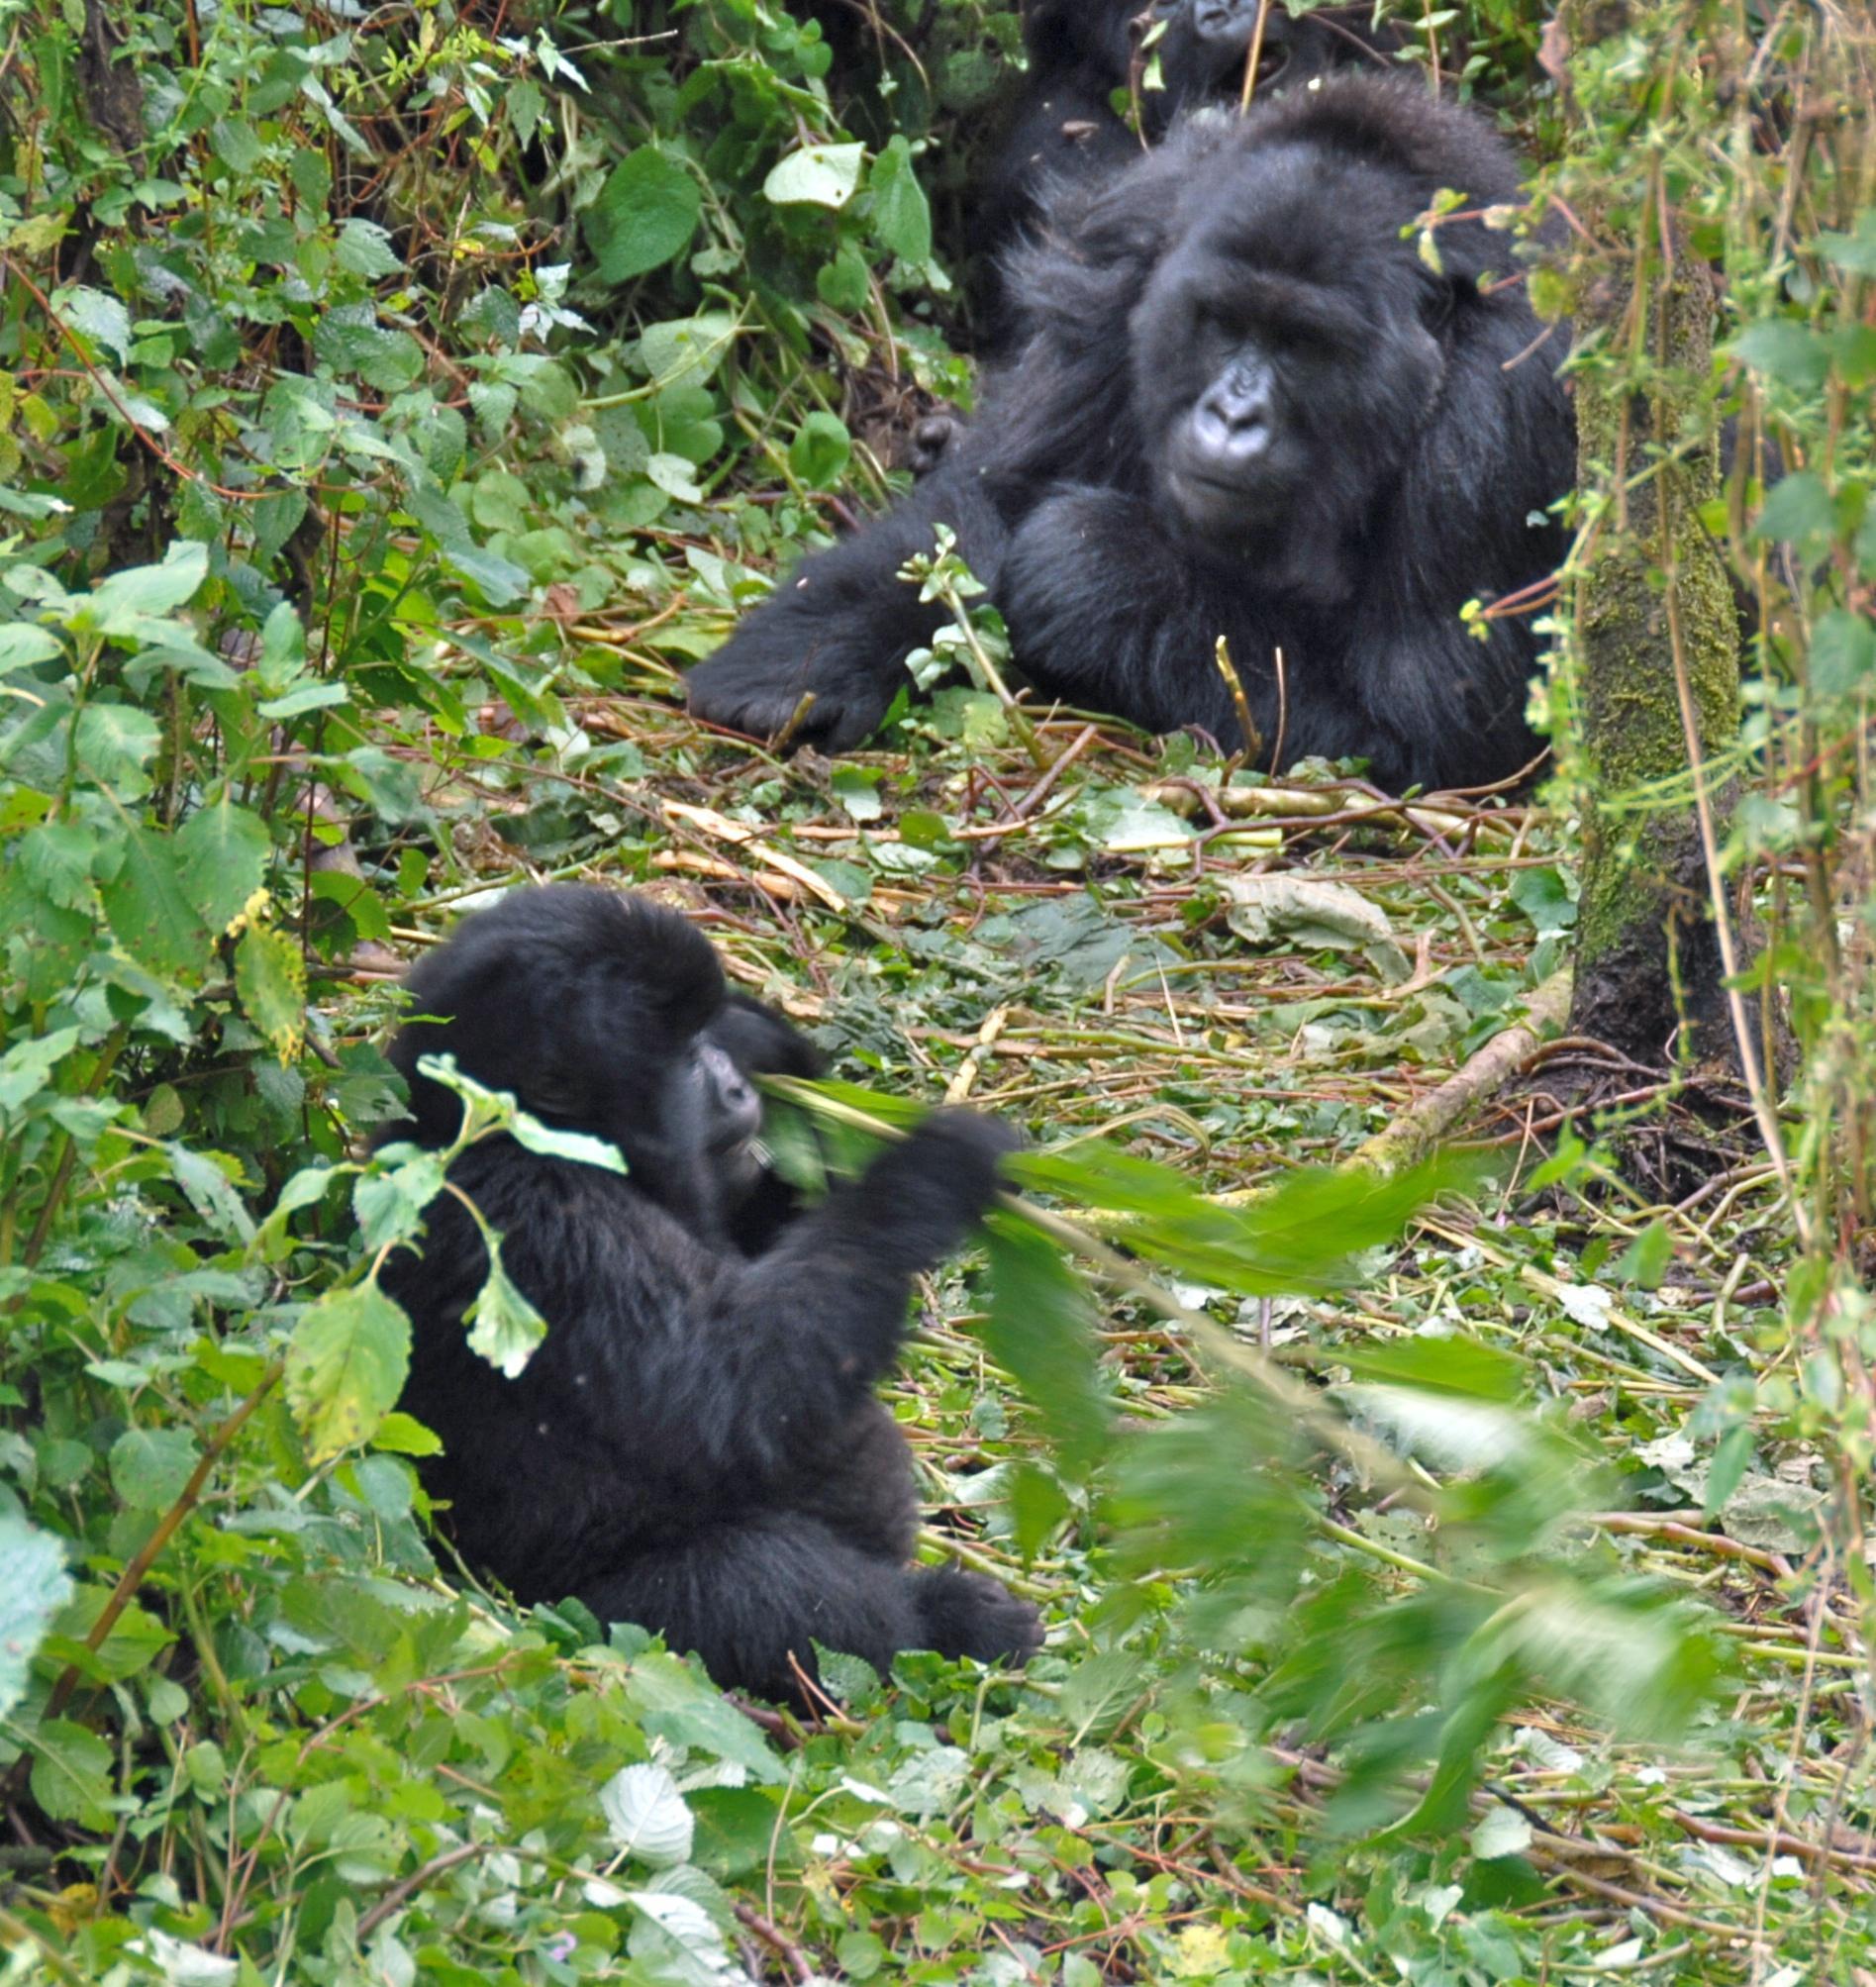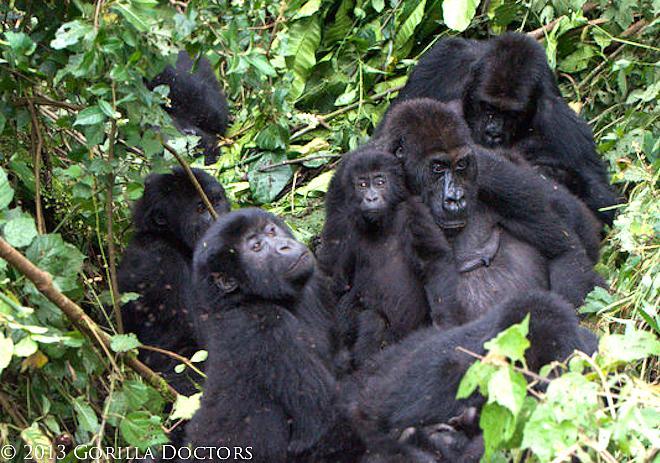The first image is the image on the left, the second image is the image on the right. Considering the images on both sides, is "There are at least 6 gorillas in the right image." valid? Answer yes or no. Yes. The first image is the image on the left, the second image is the image on the right. For the images shown, is this caption "There are no more than five gorillas." true? Answer yes or no. No. 